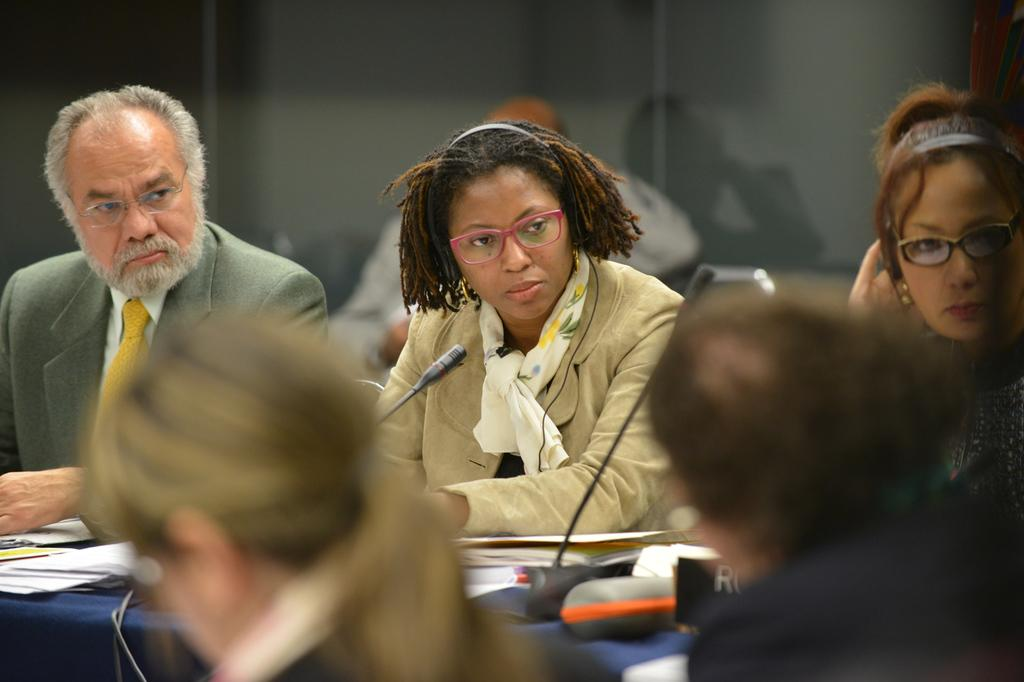What are the people in the image doing? The people are sitting in front of a table. What objects can be seen on the table? There are books, papers, and a microphone on the table. How many baby plants are growing on the table in the image? There are no baby plants visible in the image; the table only contains books, papers, and a microphone. 